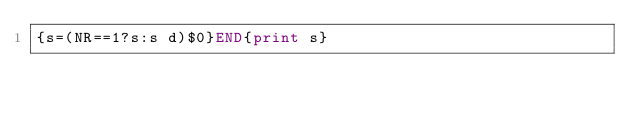Convert code to text. <code><loc_0><loc_0><loc_500><loc_500><_Awk_>{s=(NR==1?s:s d)$0}END{print s}
</code> 